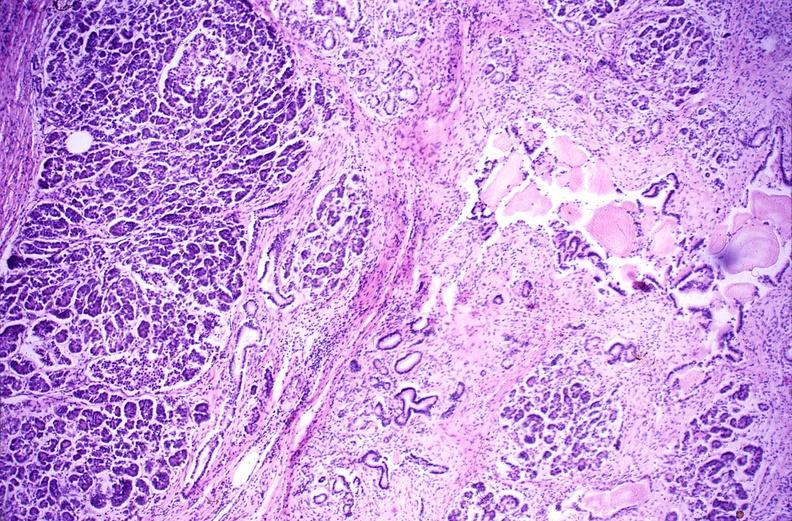does normal ovary show chronic pancreatitis?
Answer the question using a single word or phrase. No 